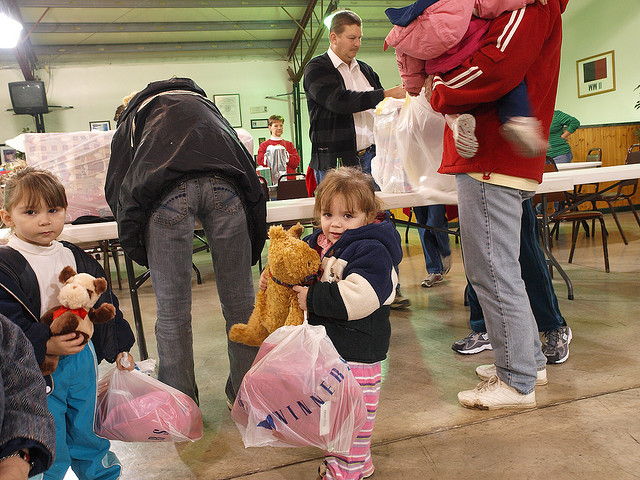Read all the text in this image. WINNER 